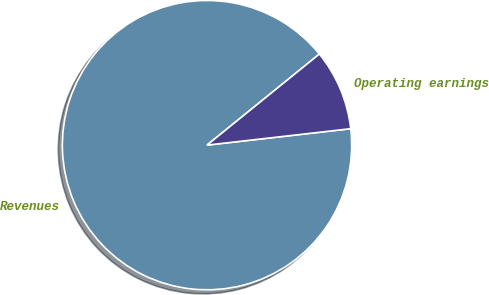Convert chart to OTSL. <chart><loc_0><loc_0><loc_500><loc_500><pie_chart><fcel>Revenues<fcel>Operating earnings<nl><fcel>90.97%<fcel>9.03%<nl></chart> 